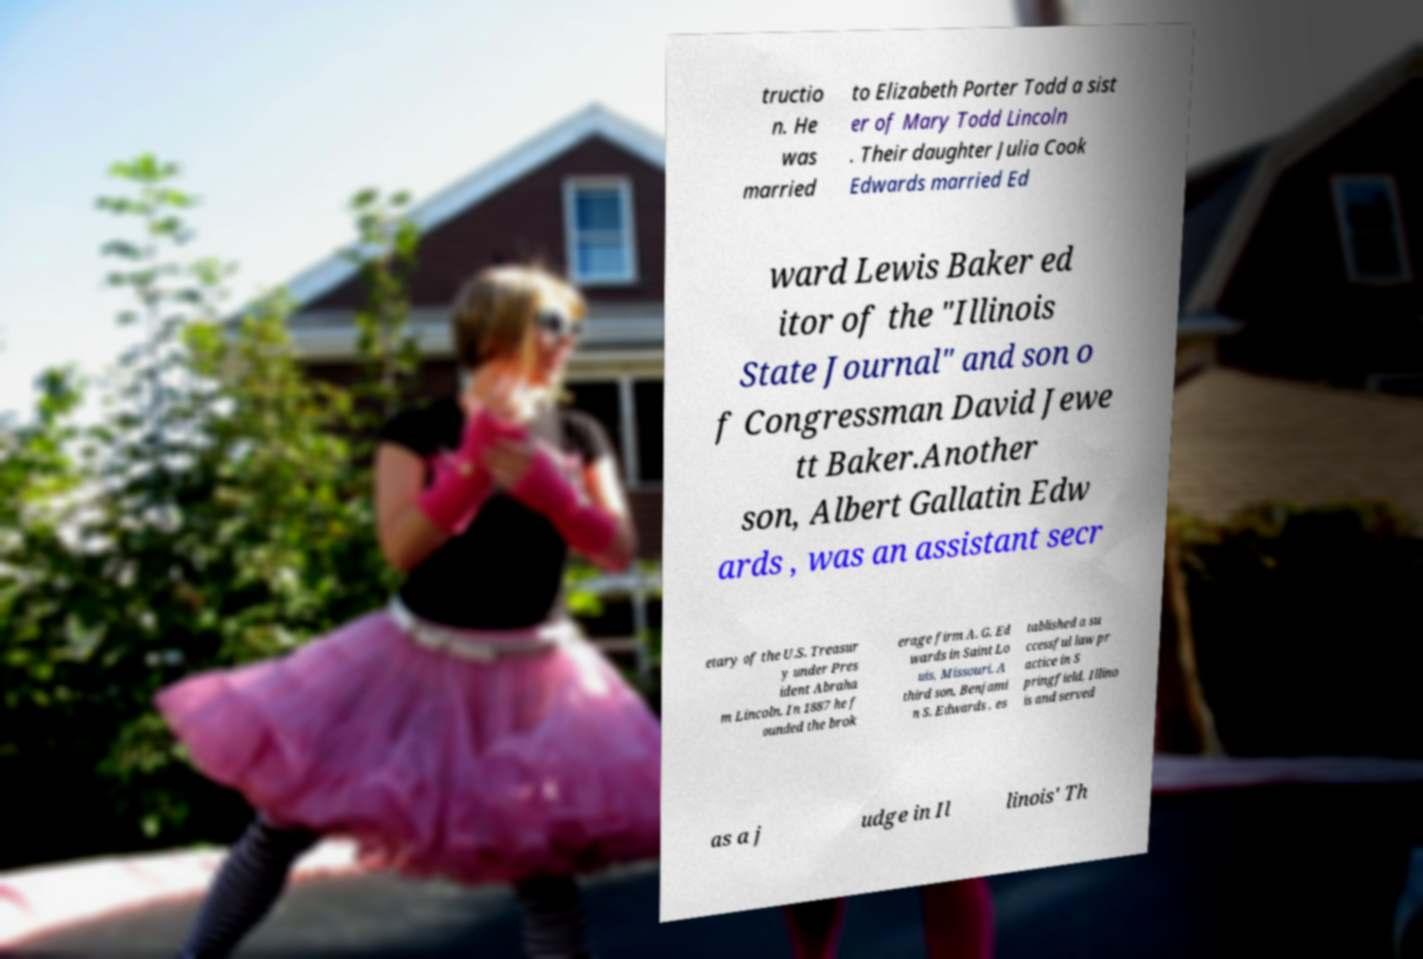Please read and relay the text visible in this image. What does it say? tructio n. He was married to Elizabeth Porter Todd a sist er of Mary Todd Lincoln . Their daughter Julia Cook Edwards married Ed ward Lewis Baker ed itor of the "Illinois State Journal" and son o f Congressman David Jewe tt Baker.Another son, Albert Gallatin Edw ards , was an assistant secr etary of the U.S. Treasur y under Pres ident Abraha m Lincoln. In 1887 he f ounded the brok erage firm A. G. Ed wards in Saint Lo uis, Missouri. A third son, Benjami n S. Edwards , es tablished a su ccessful law pr actice in S pringfield, Illino is and served as a j udge in Il linois' Th 